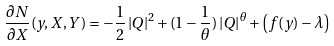<formula> <loc_0><loc_0><loc_500><loc_500>\frac { \partial N } { \partial X } ( y , X , Y ) = - \frac { 1 } { 2 } \left | Q \right | ^ { 2 } + ( 1 - \frac { 1 } { \theta } ) \left | Q \right | ^ { \theta } + \left ( f ( y ) - \lambda \right )</formula> 